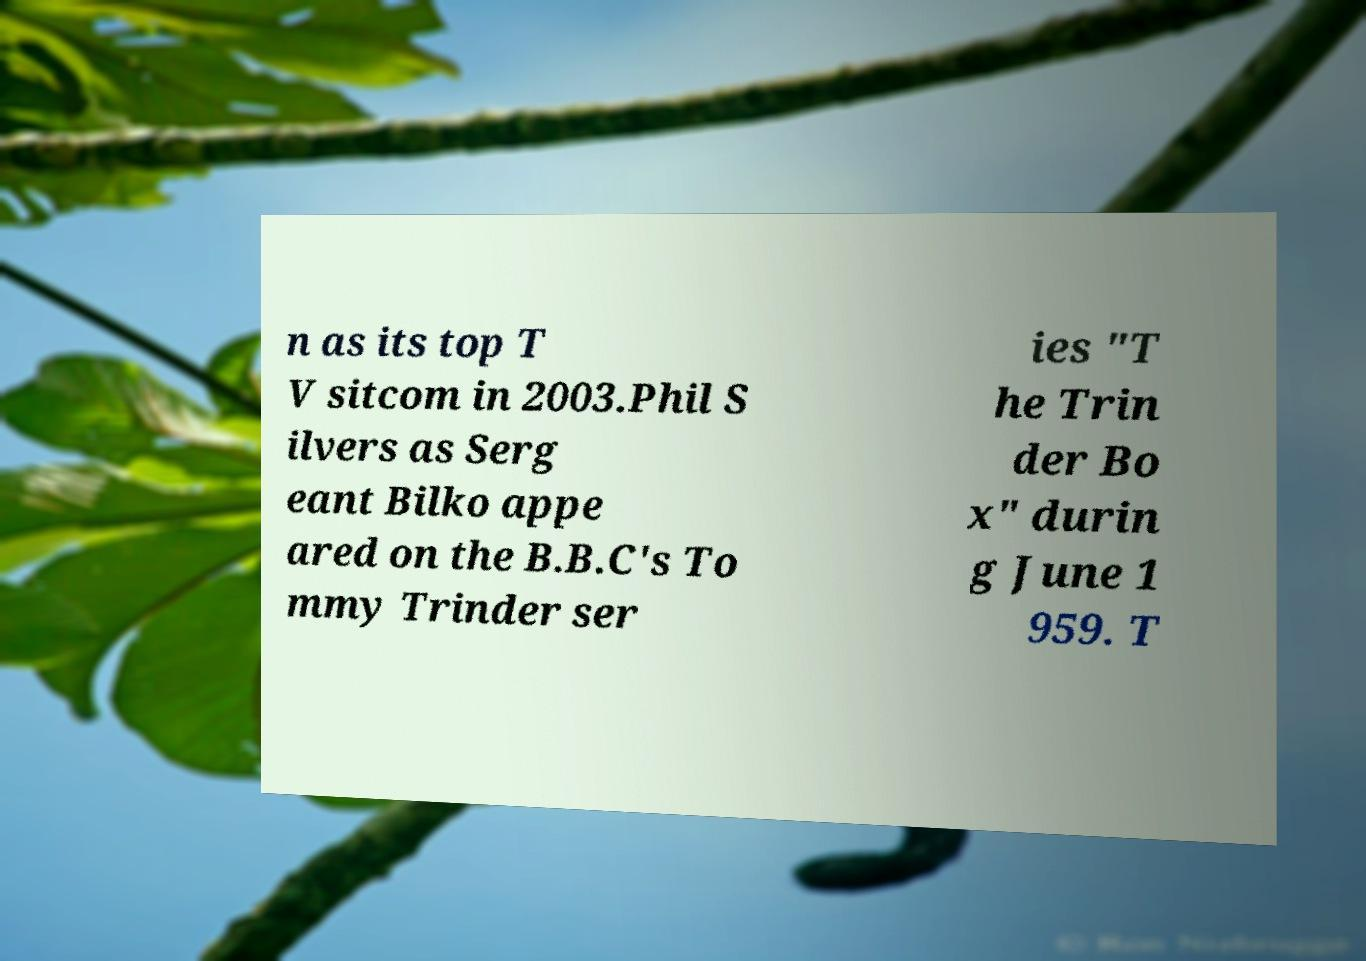Could you assist in decoding the text presented in this image and type it out clearly? n as its top T V sitcom in 2003.Phil S ilvers as Serg eant Bilko appe ared on the B.B.C's To mmy Trinder ser ies "T he Trin der Bo x" durin g June 1 959. T 